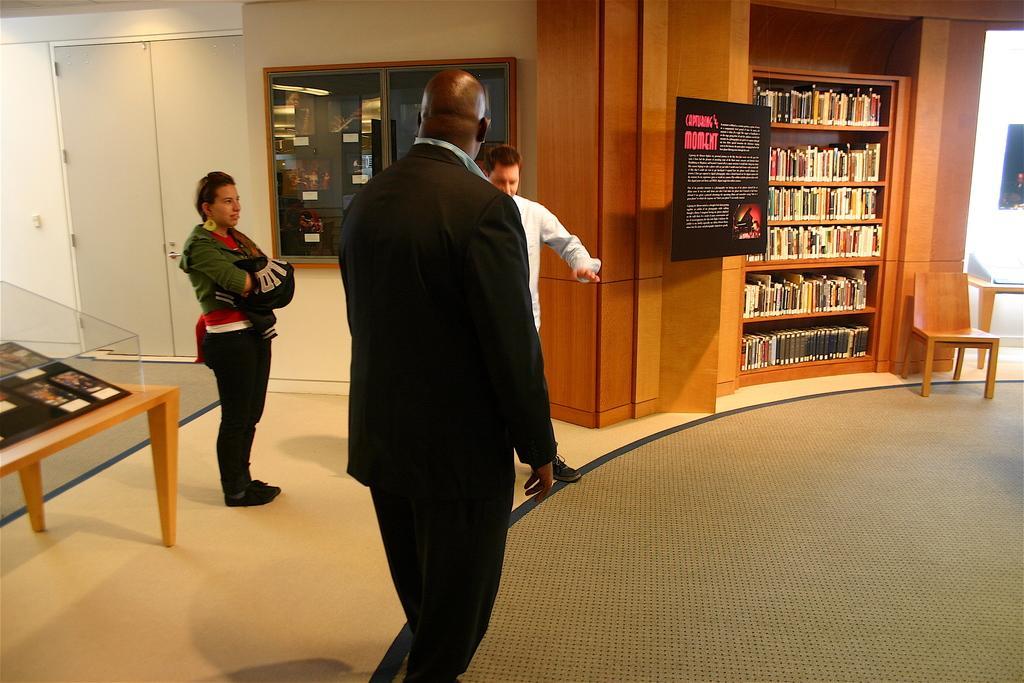Describe this image in one or two sentences. In this picture i could see three persons in the library, in the right there are cabinets in which books are arranged and a chair and a table to the right of the picture there is a carpet to the right corner. In the left there is a door and a glass bulletin board and to the left there is a table and some thing displayed on it. 